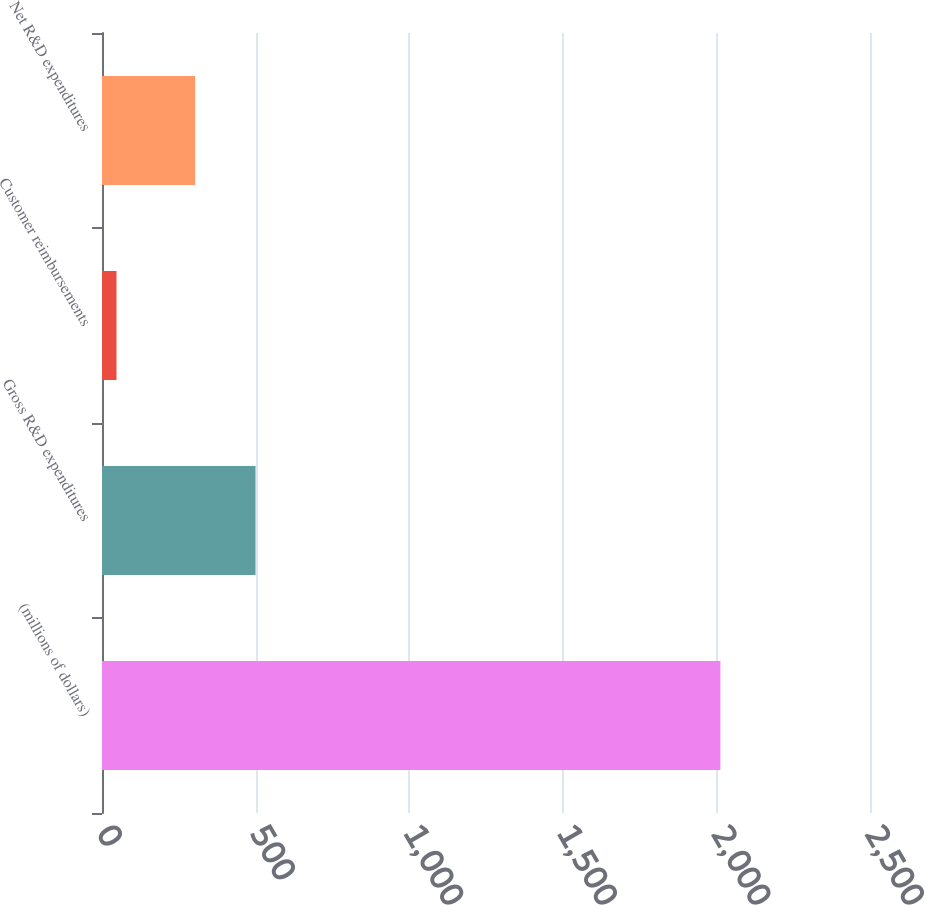Convert chart. <chart><loc_0><loc_0><loc_500><loc_500><bar_chart><fcel>(millions of dollars)<fcel>Gross R&D expenditures<fcel>Customer reimbursements<fcel>Net R&D expenditures<nl><fcel>2013<fcel>499.78<fcel>47.2<fcel>303.2<nl></chart> 